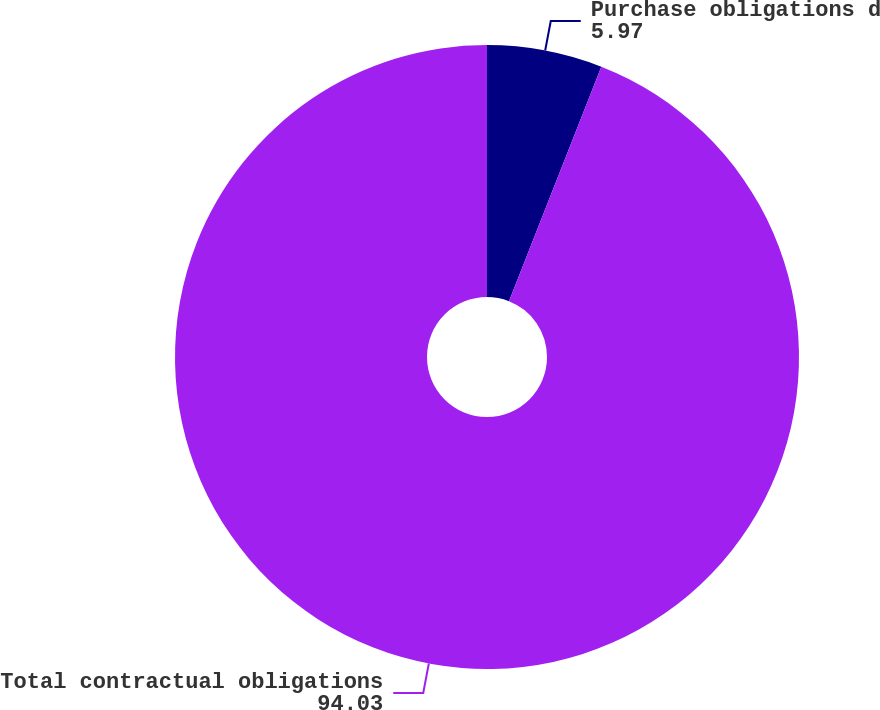<chart> <loc_0><loc_0><loc_500><loc_500><pie_chart><fcel>Purchase obligations d<fcel>Total contractual obligations<nl><fcel>5.97%<fcel>94.03%<nl></chart> 